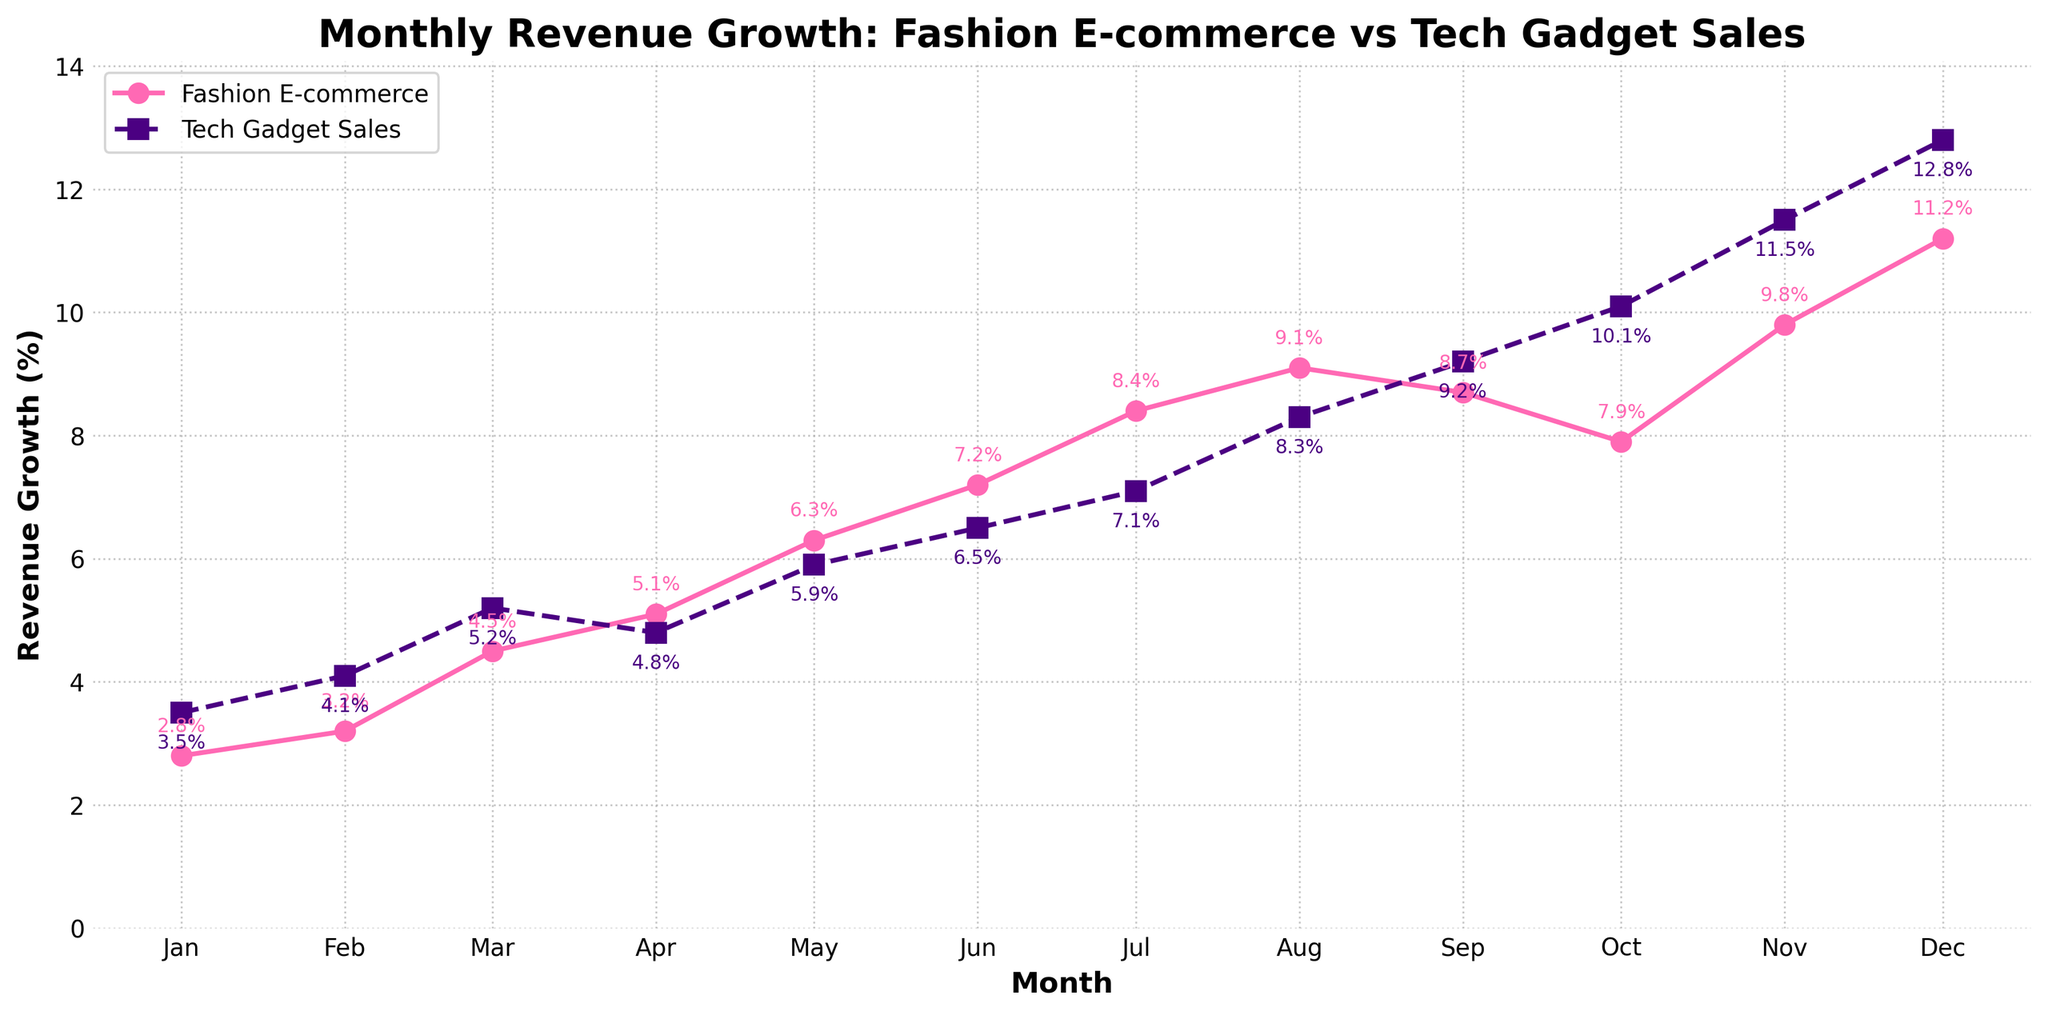What's the highest monthly revenue growth for fashion e-commerce? The highest point on the fashion e-commerce revenue growth line is in December, according to the figure.
Answer: 11.2% Which month shows a higher revenue growth for tech gadget sales compared to fashion e-commerce? In the month of October, tech gadget sales revenue growth is higher than fashion e-commerce growth, with tech at 10.1% and fashion at 7.9%.
Answer: October What is the difference in revenue growth between fashion e-commerce and tech gadget sales in November? The November growth for fashion e-commerce is 9.8%, and for tech gadget sales, it is 11.5%. The difference is 11.5% - 9.8%.
Answer: 1.7% In which months does tech gadget sales revenue growth surpass fashion e-commerce revenue growth? From October to December, tech gadget sales growth is higher than fashion e-commerce.
Answer: October, November, December What is the average revenue growth for fashion e-commerce over the year? Sum the monthly growth values (2.8% + 3.2% + 4.5% + 5.1% + 6.3% + 7.2% + 8.4% + 9.1% + 8.7% + 7.9% + 9.8% + 11.2%) and divide by 12. The sum is 84.2%, so the average is 84.2% / 12.
Answer: 7.02% How does the growth trend for fashion e-commerce compare visually to tech gadget sales over the year? The fashion e-commerce line has a smoother and steadier upward trend compared to the tech gadget sales line, which has some more pronounced increases towards the end of the year.
Answer: Fashion is smoother and steadier; tech is more pronounced end-of-year growth What's the combined total percentage growth for both sectors in January 2023? Add the growth percentages for fashion e-commerce and tech gadget sales for January: 2.8% + 3.5%.
Answer: 6.3% In which month is the revenue growth gap between the two sectors the smallest? Comparing the differences month by month, the smallest gap is in September, with fashion at 8.7% and tech at 9.2%, a difference of 0.5%.
Answer: September What trends are noticeable about fashion e-commerce revenue growth in the mid-year months? From April to August, the fashion e-commerce revenue growth steadily increases from 5.1% to 9.1%, showing a clear upward trend.
Answer: Steady increase from April to August In which month did tech gadget sales revenue growth first exceed 10%? The tech gadget sales revenue growth first exceeded 10% in October.
Answer: October 